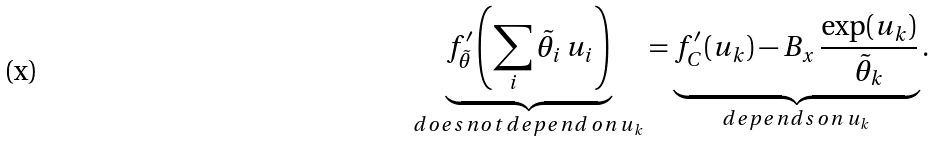<formula> <loc_0><loc_0><loc_500><loc_500>\underbrace { f ^ { \prime } _ { \tilde { \theta } } \left ( \sum _ { i } { \tilde { \theta } _ { i } \, u _ { i } } \right ) } _ { d o e s \, n o t \, d e p e n d \, o n \, u _ { k } } = \underbrace { f ^ { \prime } _ { C } ( u _ { k } ) - B _ { x } \, \frac { \exp ( u _ { k } ) } { \tilde { \theta } _ { k } } } _ { d e p e n d s \, o n \, u _ { k } } .</formula> 